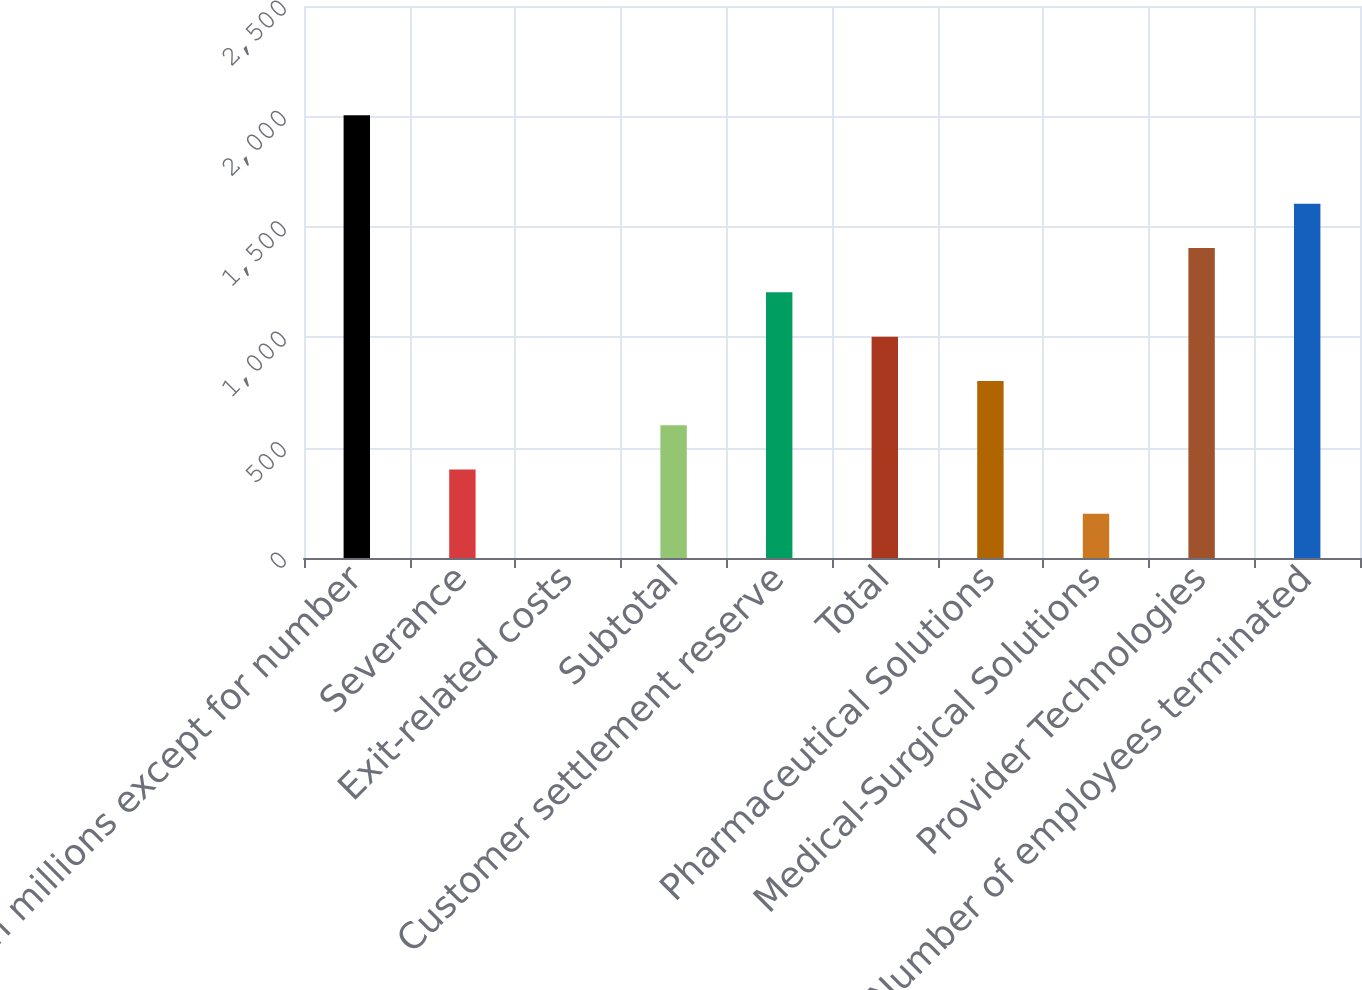Convert chart. <chart><loc_0><loc_0><loc_500><loc_500><bar_chart><fcel>(In millions except for number<fcel>Severance<fcel>Exit-related costs<fcel>Subtotal<fcel>Customer settlement reserve<fcel>Total<fcel>Pharmaceutical Solutions<fcel>Medical-Surgical Solutions<fcel>Provider Technologies<fcel>Number of employees terminated<nl><fcel>2005<fcel>401.08<fcel>0.1<fcel>601.57<fcel>1203.04<fcel>1002.55<fcel>802.06<fcel>200.59<fcel>1403.53<fcel>1604.02<nl></chart> 